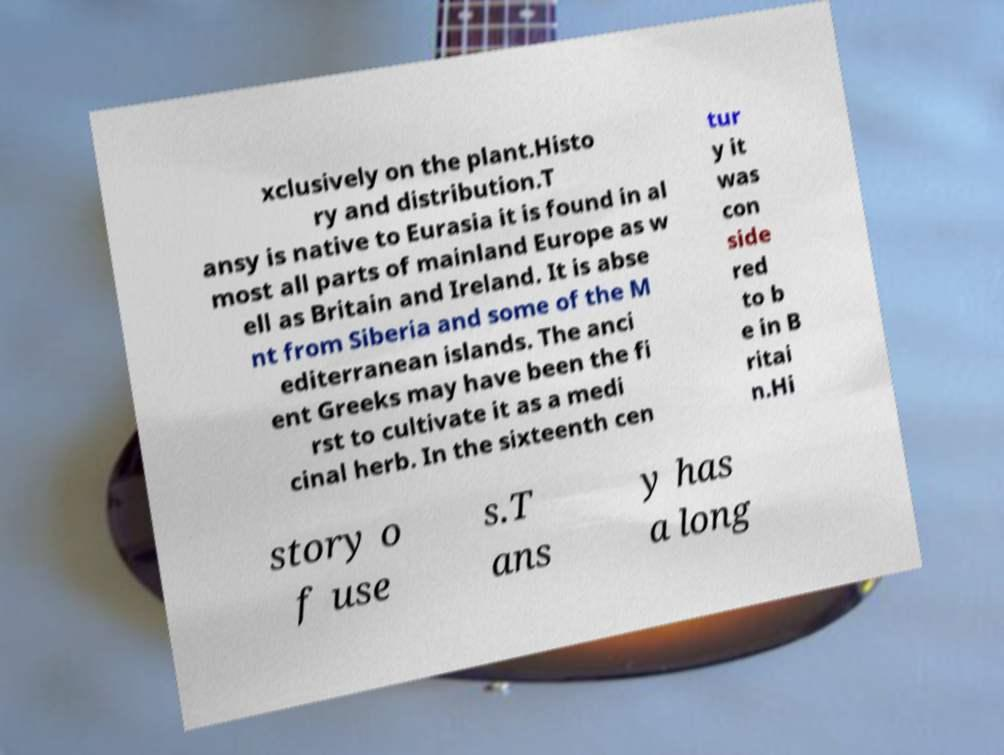Please identify and transcribe the text found in this image. xclusively on the plant.Histo ry and distribution.T ansy is native to Eurasia it is found in al most all parts of mainland Europe as w ell as Britain and Ireland. It is abse nt from Siberia and some of the M editerranean islands. The anci ent Greeks may have been the fi rst to cultivate it as a medi cinal herb. In the sixteenth cen tur y it was con side red to b e in B ritai n.Hi story o f use s.T ans y has a long 